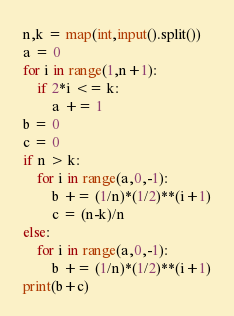<code> <loc_0><loc_0><loc_500><loc_500><_Python_>n,k = map(int,input().split())
a = 0
for i in range(1,n+1):
    if 2*i <= k:
        a += 1
b = 0
c = 0
if n > k:
    for i in range(a,0,-1):
        b += (1/n)*(1/2)**(i+1)
        c = (n-k)/n
else:
    for i in range(a,0,-1):
        b += (1/n)*(1/2)**(i+1)
print(b+c)</code> 